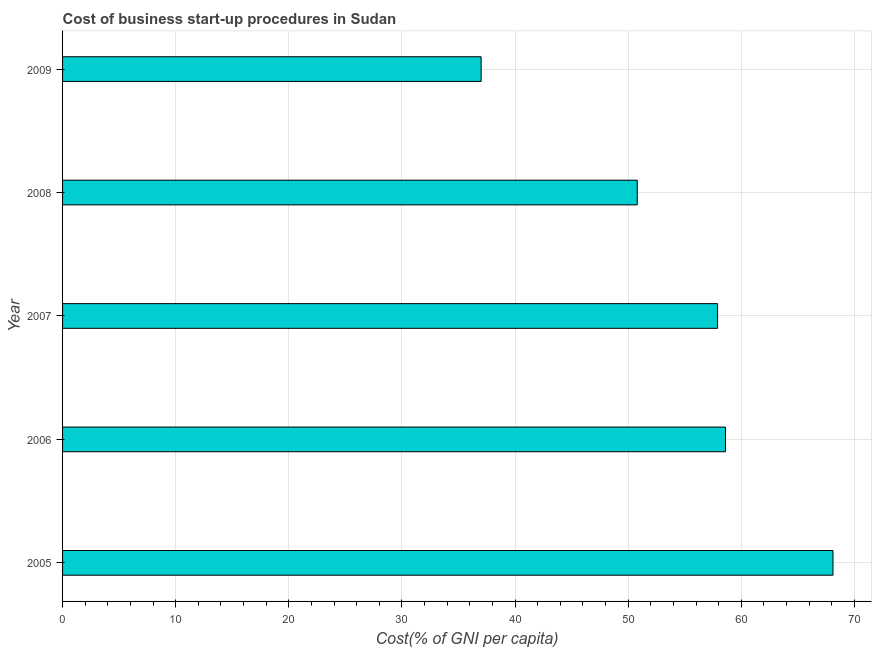Does the graph contain any zero values?
Provide a short and direct response. No. What is the title of the graph?
Your answer should be compact. Cost of business start-up procedures in Sudan. What is the label or title of the X-axis?
Offer a terse response. Cost(% of GNI per capita). What is the label or title of the Y-axis?
Your answer should be very brief. Year. What is the cost of business startup procedures in 2007?
Ensure brevity in your answer.  57.9. Across all years, what is the maximum cost of business startup procedures?
Provide a succinct answer. 68.1. In which year was the cost of business startup procedures maximum?
Offer a very short reply. 2005. In which year was the cost of business startup procedures minimum?
Offer a terse response. 2009. What is the sum of the cost of business startup procedures?
Your response must be concise. 272.4. What is the difference between the cost of business startup procedures in 2006 and 2007?
Offer a very short reply. 0.7. What is the average cost of business startup procedures per year?
Keep it short and to the point. 54.48. What is the median cost of business startup procedures?
Your answer should be very brief. 57.9. Do a majority of the years between 2008 and 2006 (inclusive) have cost of business startup procedures greater than 44 %?
Provide a short and direct response. Yes. What is the ratio of the cost of business startup procedures in 2006 to that in 2009?
Your response must be concise. 1.58. Is the cost of business startup procedures in 2006 less than that in 2008?
Ensure brevity in your answer.  No. Is the difference between the cost of business startup procedures in 2005 and 2008 greater than the difference between any two years?
Make the answer very short. No. What is the difference between the highest and the second highest cost of business startup procedures?
Provide a succinct answer. 9.5. Is the sum of the cost of business startup procedures in 2005 and 2008 greater than the maximum cost of business startup procedures across all years?
Offer a very short reply. Yes. What is the difference between the highest and the lowest cost of business startup procedures?
Keep it short and to the point. 31.1. Are all the bars in the graph horizontal?
Make the answer very short. Yes. What is the difference between two consecutive major ticks on the X-axis?
Provide a succinct answer. 10. What is the Cost(% of GNI per capita) of 2005?
Your response must be concise. 68.1. What is the Cost(% of GNI per capita) in 2006?
Your answer should be compact. 58.6. What is the Cost(% of GNI per capita) of 2007?
Keep it short and to the point. 57.9. What is the Cost(% of GNI per capita) in 2008?
Make the answer very short. 50.8. What is the difference between the Cost(% of GNI per capita) in 2005 and 2007?
Provide a succinct answer. 10.2. What is the difference between the Cost(% of GNI per capita) in 2005 and 2008?
Your answer should be very brief. 17.3. What is the difference between the Cost(% of GNI per capita) in 2005 and 2009?
Offer a terse response. 31.1. What is the difference between the Cost(% of GNI per capita) in 2006 and 2009?
Offer a terse response. 21.6. What is the difference between the Cost(% of GNI per capita) in 2007 and 2009?
Ensure brevity in your answer.  20.9. What is the difference between the Cost(% of GNI per capita) in 2008 and 2009?
Ensure brevity in your answer.  13.8. What is the ratio of the Cost(% of GNI per capita) in 2005 to that in 2006?
Provide a short and direct response. 1.16. What is the ratio of the Cost(% of GNI per capita) in 2005 to that in 2007?
Keep it short and to the point. 1.18. What is the ratio of the Cost(% of GNI per capita) in 2005 to that in 2008?
Your response must be concise. 1.34. What is the ratio of the Cost(% of GNI per capita) in 2005 to that in 2009?
Offer a very short reply. 1.84. What is the ratio of the Cost(% of GNI per capita) in 2006 to that in 2007?
Provide a succinct answer. 1.01. What is the ratio of the Cost(% of GNI per capita) in 2006 to that in 2008?
Your answer should be very brief. 1.15. What is the ratio of the Cost(% of GNI per capita) in 2006 to that in 2009?
Offer a very short reply. 1.58. What is the ratio of the Cost(% of GNI per capita) in 2007 to that in 2008?
Give a very brief answer. 1.14. What is the ratio of the Cost(% of GNI per capita) in 2007 to that in 2009?
Your answer should be very brief. 1.56. What is the ratio of the Cost(% of GNI per capita) in 2008 to that in 2009?
Ensure brevity in your answer.  1.37. 